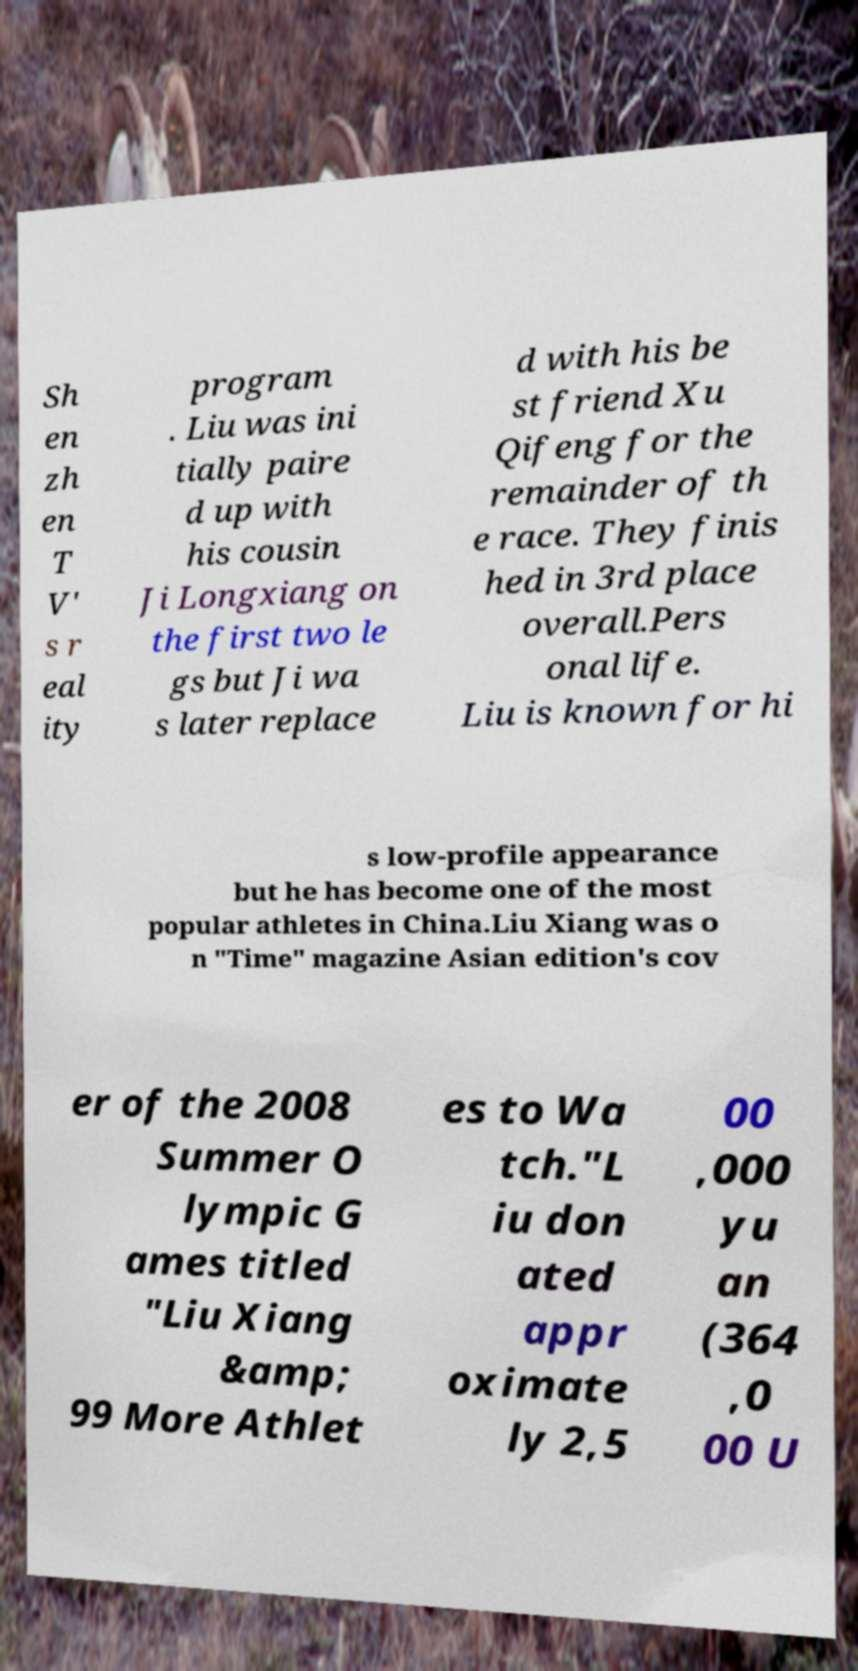Please identify and transcribe the text found in this image. Sh en zh en T V' s r eal ity program . Liu was ini tially paire d up with his cousin Ji Longxiang on the first two le gs but Ji wa s later replace d with his be st friend Xu Qifeng for the remainder of th e race. They finis hed in 3rd place overall.Pers onal life. Liu is known for hi s low-profile appearance but he has become one of the most popular athletes in China.Liu Xiang was o n "Time" magazine Asian edition's cov er of the 2008 Summer O lympic G ames titled "Liu Xiang &amp; 99 More Athlet es to Wa tch."L iu don ated appr oximate ly 2,5 00 ,000 yu an (364 ,0 00 U 